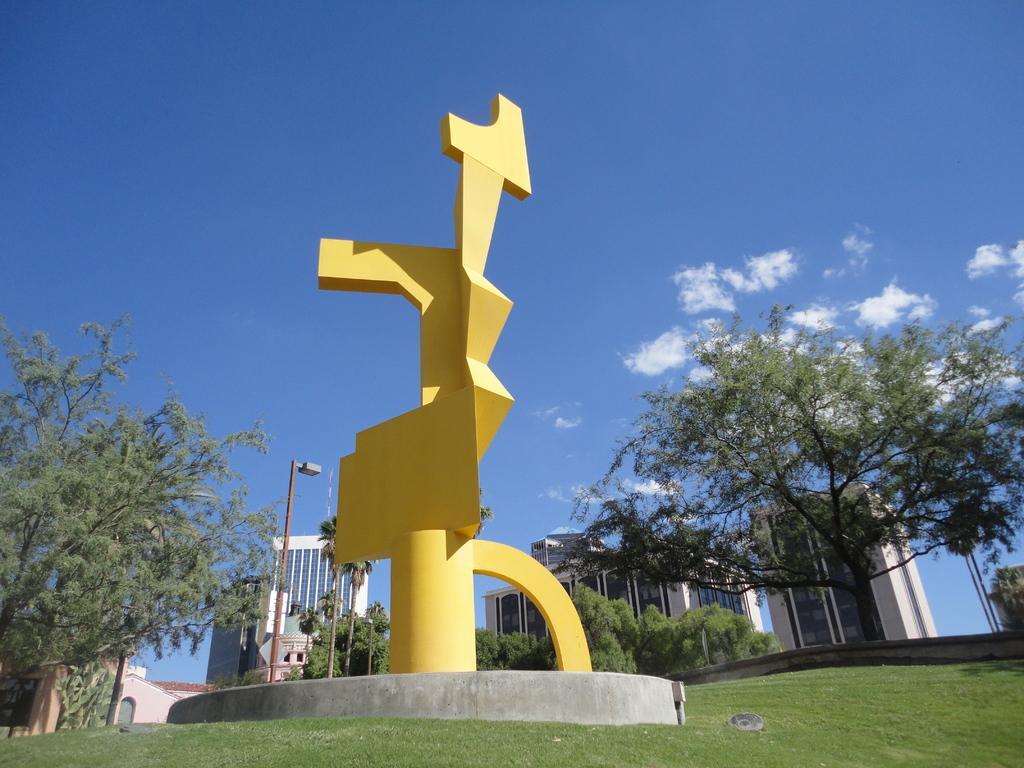Can you describe this image briefly? This picture is clicked outside. In the foreground we can see the green grass. In the center there is a yellow object. In the background we can see the sky, buildings, trees and a light attached to the pole. 